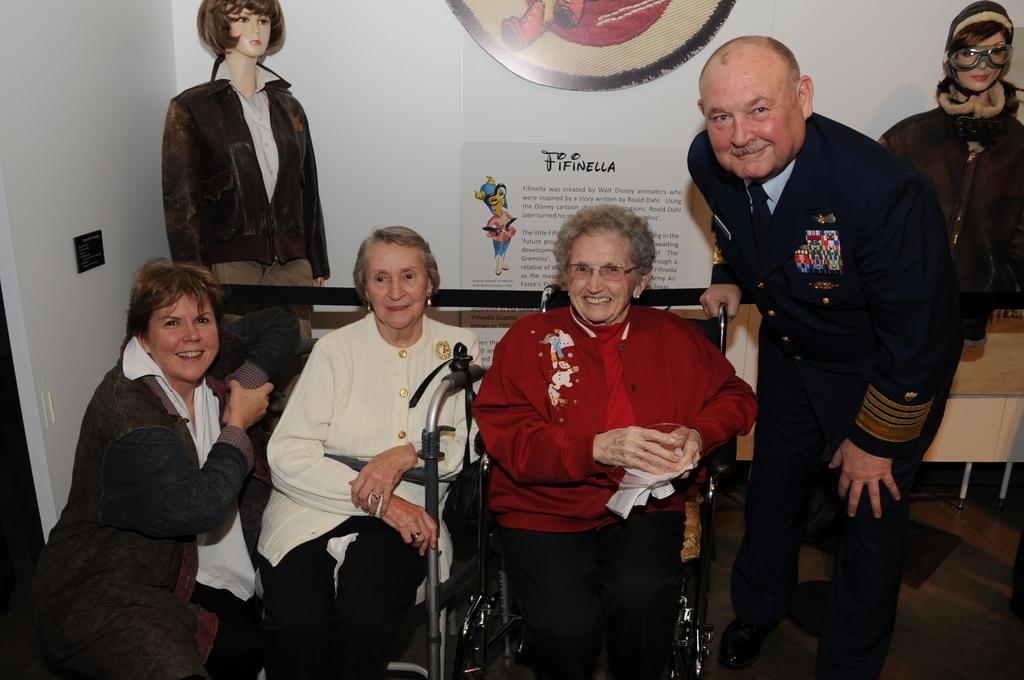What are the people in the image doing? There are people sitting and standing in the image. What other objects or figures can be seen in the image? There are mannequins in the image. What is on the wall in the image? There are posters on the wall in the image. What type of yarn is being used by the beggar in the image? There is no beggar present in the image. 